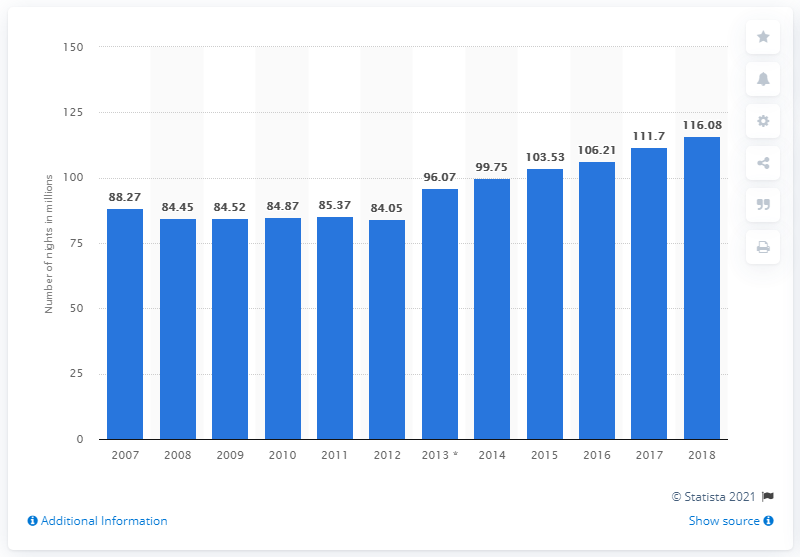List a handful of essential elements in this visual. During the period of 2007 to 2018, a total of 116.08 nights were spent at tourist accommodation establishments in the Netherlands. 